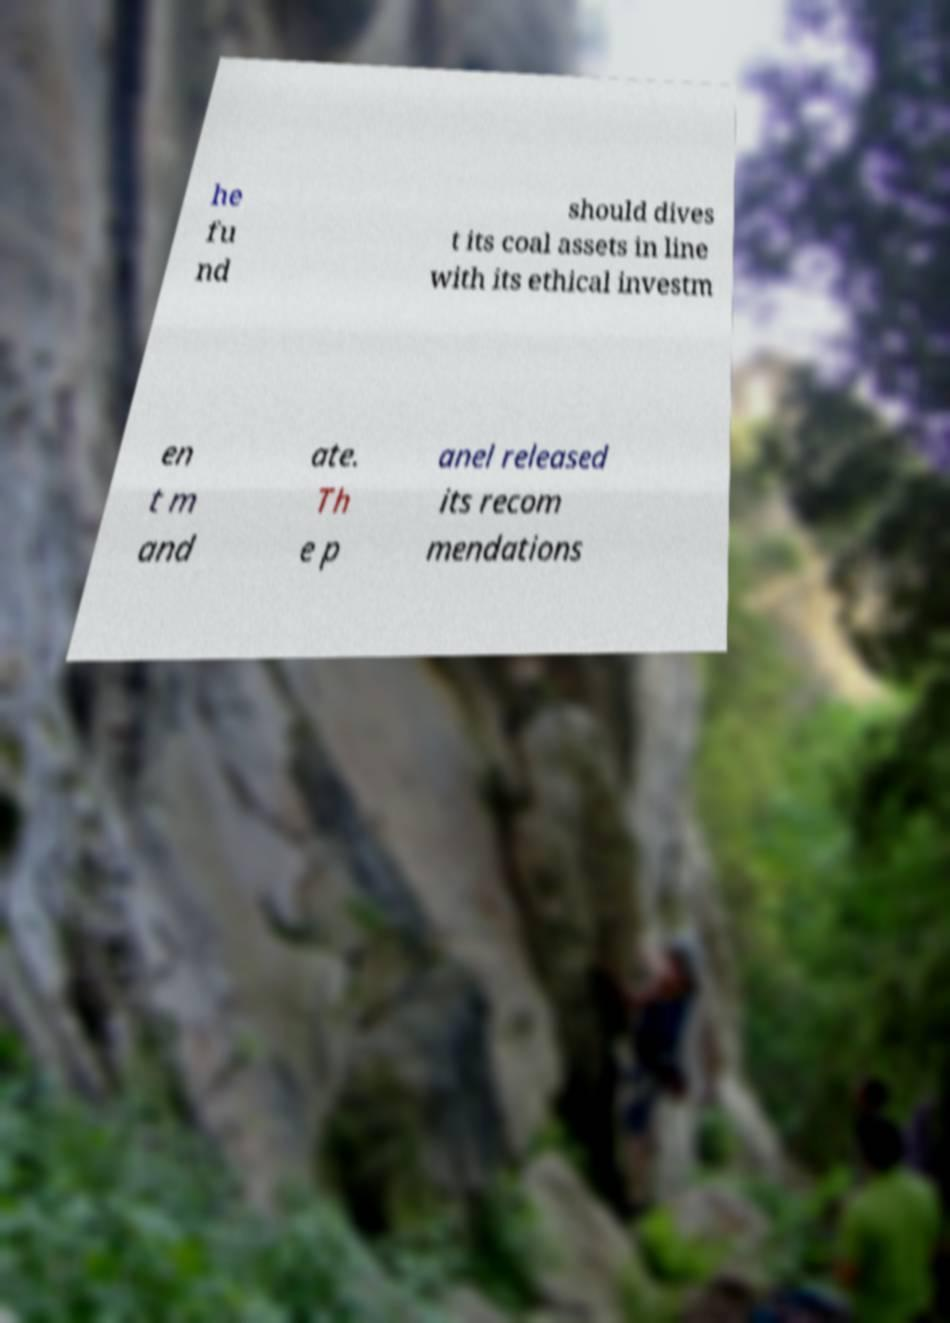For documentation purposes, I need the text within this image transcribed. Could you provide that? he fu nd should dives t its coal assets in line with its ethical investm en t m and ate. Th e p anel released its recom mendations 